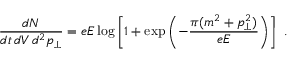<formula> <loc_0><loc_0><loc_500><loc_500>\frac { d N } { d t \, d V \, d ^ { 2 } p _ { \perp } } = e E \log \left [ 1 + \exp \left ( - \frac { \pi ( m ^ { 2 } + p _ { \perp } ^ { 2 } ) } { e E } \right ) \right ] \ .</formula> 